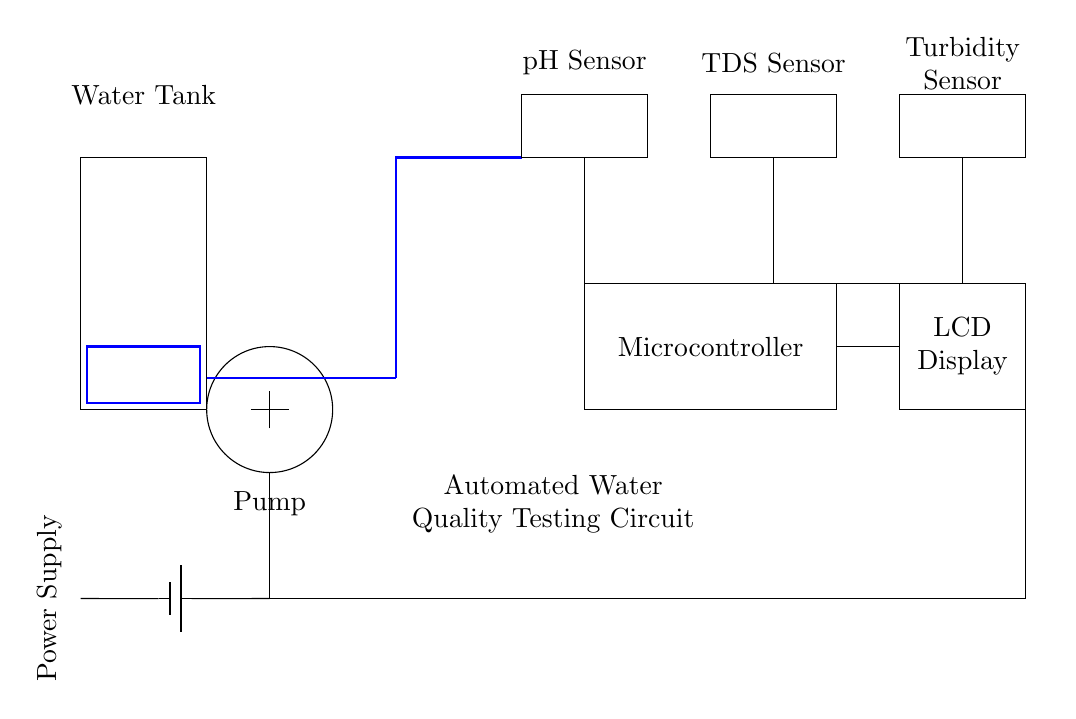What is the main function of this circuit? The circuit is designed for automated water quality testing, as indicated by the label and components included.
Answer: automated water quality testing What components are used to measure water quality? The circuit includes pH sensor, TDS sensor, and turbidity sensor, all of which are essential for measuring various aspects of water quality.
Answer: pH sensor, TDS sensor, turbidity sensor What is the role of the microcontroller in this circuit? The microcontroller processes data from the sensors and controls the circuit's operations, connecting the input from the sensors to the output displayed.
Answer: data processing How many types of sensors are in this circuit? There are three sensor types represented in the circuit diagram: pH, TDS, and turbidity.
Answer: three How does the power supply connect to the circuit? The power supply connects to the pump and microcontroller directly and supplies power through the circuit's main connections.
Answer: directly to pump and microcontroller What does the LCD display indicate in this circuit? The LCD display shows the results of the water quality measurements taken by the sensors in real-time, making it an important component of the monitoring system.
Answer: measurement results How do the sensors connect to the microcontroller? The sensors connect directly to the microcontroller with dedicated lines, allowing the microcontroller to accurately read their outputs for processing.
Answer: dedicated lines 